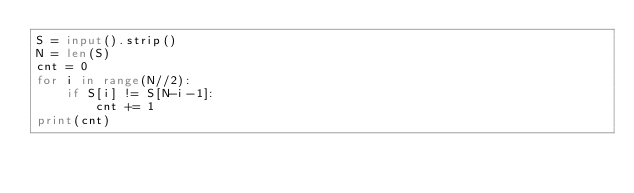Convert code to text. <code><loc_0><loc_0><loc_500><loc_500><_Python_>S = input().strip()
N = len(S)
cnt = 0
for i in range(N//2):
    if S[i] != S[N-i-1]:
        cnt += 1
print(cnt)
</code> 